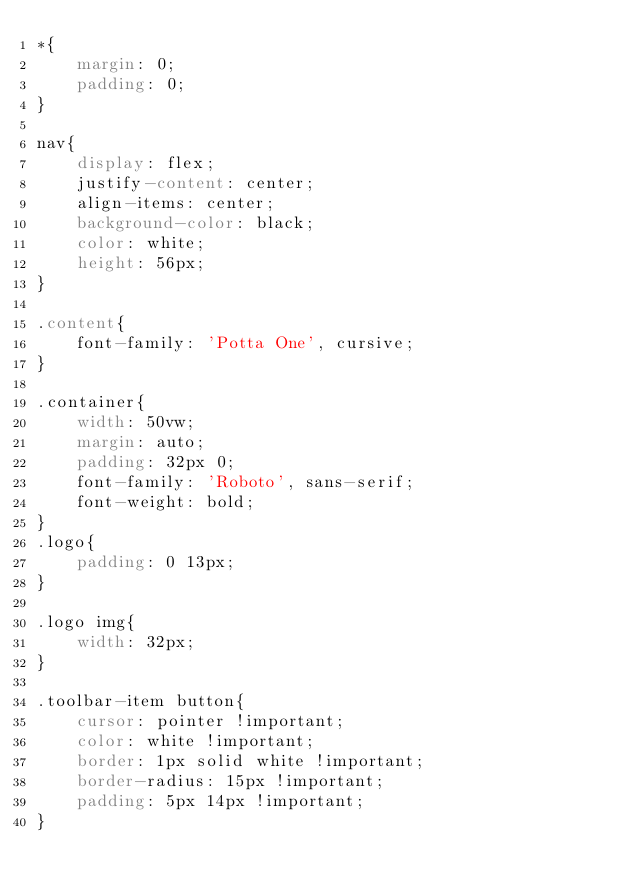Convert code to text. <code><loc_0><loc_0><loc_500><loc_500><_CSS_>*{
    margin: 0;
    padding: 0;
}

nav{
    display: flex;
    justify-content: center;
    align-items: center;
    background-color: black;
    color: white;
    height: 56px;
}

.content{
    font-family: 'Potta One', cursive;
}

.container{
    width: 50vw;
    margin: auto;
    padding: 32px 0;
    font-family: 'Roboto', sans-serif;
    font-weight: bold;
}
.logo{
    padding: 0 13px;
}

.logo img{
    width: 32px;
}

.toolbar-item button{
    cursor: pointer !important;
    color: white !important;
    border: 1px solid white !important;
    border-radius: 15px !important;
    padding: 5px 14px !important;
}</code> 